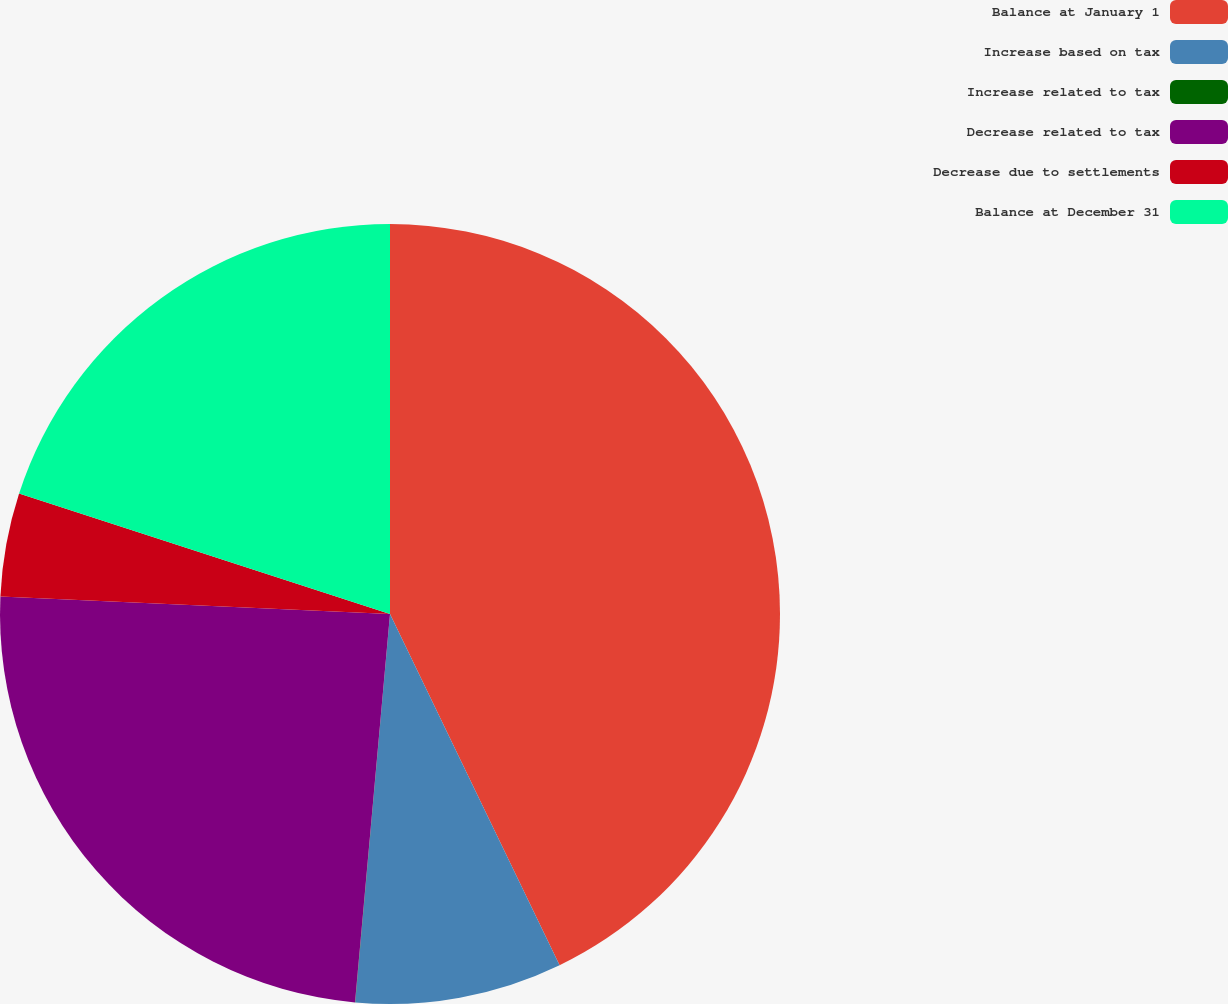Convert chart to OTSL. <chart><loc_0><loc_0><loc_500><loc_500><pie_chart><fcel>Balance at January 1<fcel>Increase based on tax<fcel>Increase related to tax<fcel>Decrease related to tax<fcel>Decrease due to settlements<fcel>Balance at December 31<nl><fcel>42.84%<fcel>8.58%<fcel>0.01%<fcel>24.28%<fcel>4.29%<fcel>20.0%<nl></chart> 